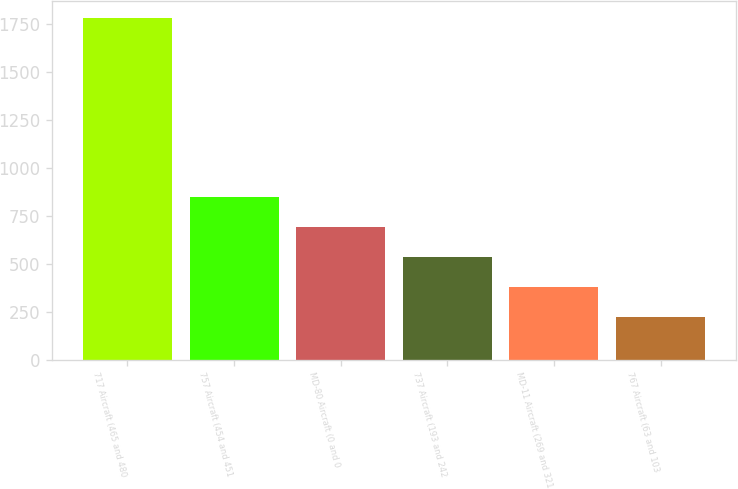Convert chart to OTSL. <chart><loc_0><loc_0><loc_500><loc_500><bar_chart><fcel>717 Aircraft (465 and 480<fcel>757 Aircraft (454 and 451<fcel>MD-80 Aircraft (0 and 0<fcel>737 Aircraft (193 and 242<fcel>MD-11 Aircraft (269 and 321<fcel>767 Aircraft (63 and 103<nl><fcel>1781<fcel>846.2<fcel>690.4<fcel>534.6<fcel>378.8<fcel>223<nl></chart> 